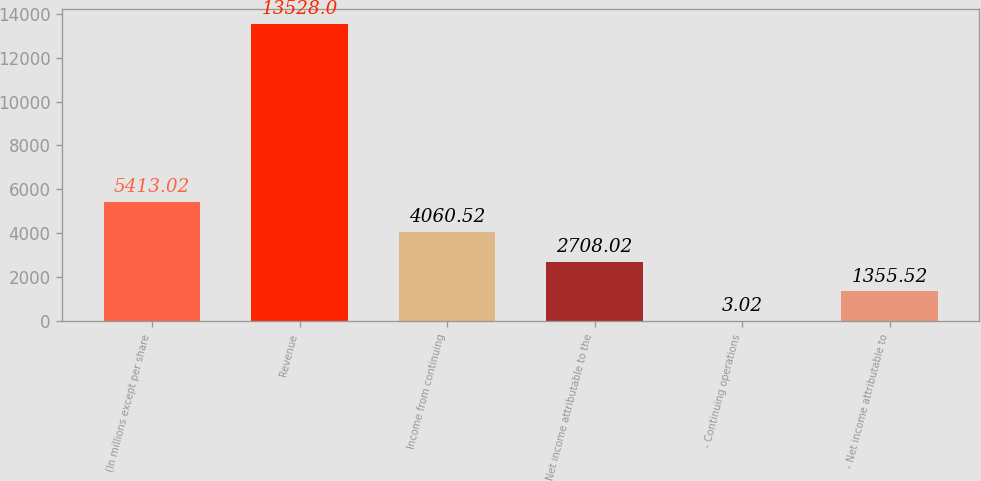Convert chart to OTSL. <chart><loc_0><loc_0><loc_500><loc_500><bar_chart><fcel>(In millions except per share<fcel>Revenue<fcel>Income from continuing<fcel>Net income attributable to the<fcel>- Continuing operations<fcel>- Net income attributable to<nl><fcel>5413.02<fcel>13528<fcel>4060.52<fcel>2708.02<fcel>3.02<fcel>1355.52<nl></chart> 